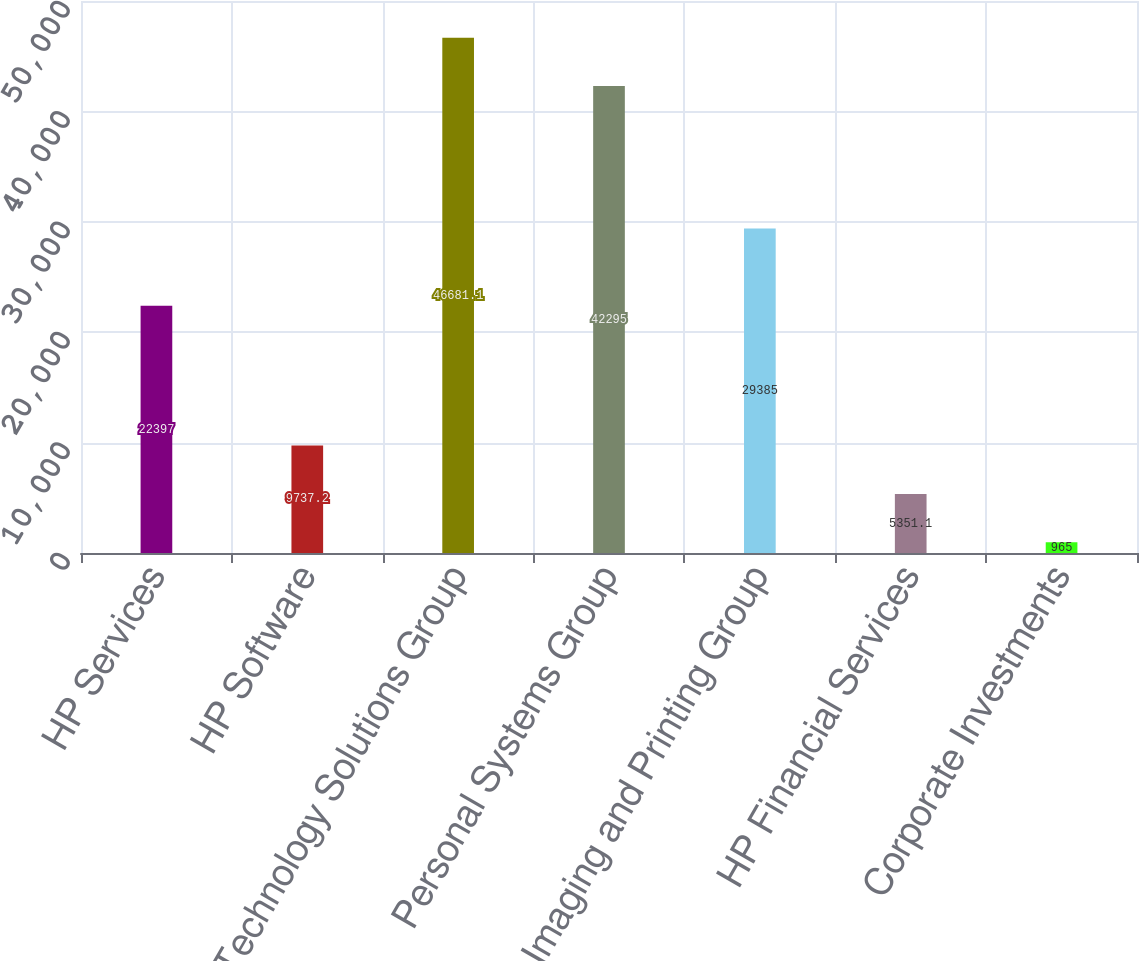<chart> <loc_0><loc_0><loc_500><loc_500><bar_chart><fcel>HP Services<fcel>HP Software<fcel>Technology Solutions Group<fcel>Personal Systems Group<fcel>Imaging and Printing Group<fcel>HP Financial Services<fcel>Corporate Investments<nl><fcel>22397<fcel>9737.2<fcel>46681.1<fcel>42295<fcel>29385<fcel>5351.1<fcel>965<nl></chart> 